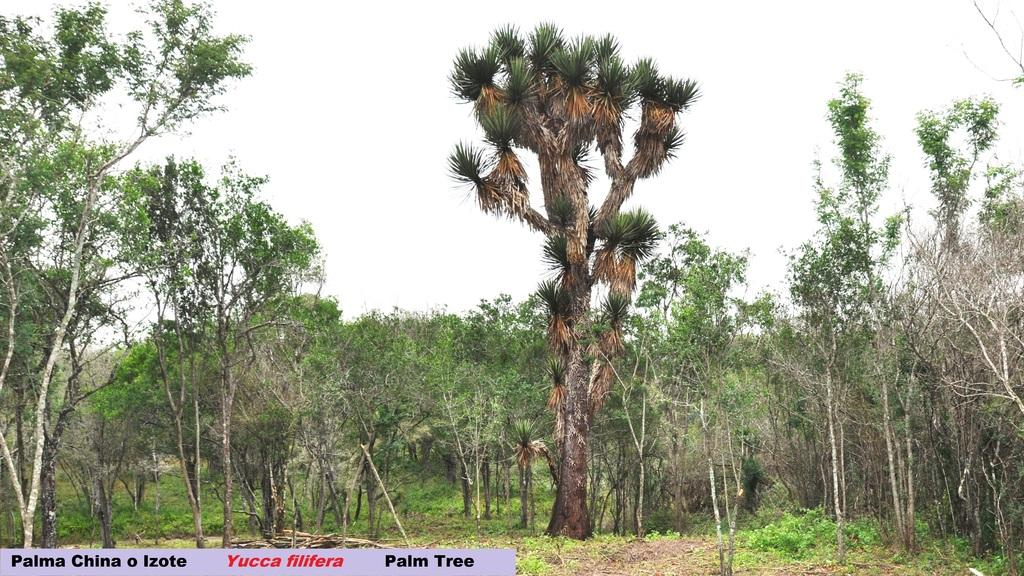What type of natural elements can be seen on the ground in the image? There are trees and plants on the ground in the image. What is visible at the top of the image? The sky is visible at the top of the image. Is there any text present in the image? Yes, there is text written on the image. What type of carpenter is depicted in the image? There is no carpenter present in the image. How does the concept of death relate to the image? The image does not depict or reference any concept of death. 